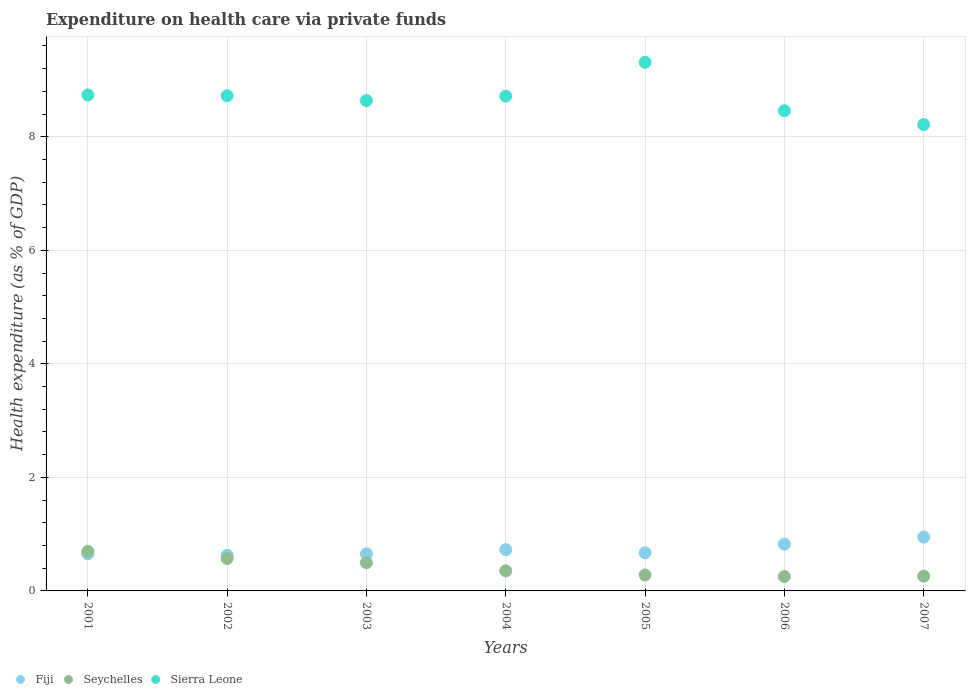How many different coloured dotlines are there?
Your response must be concise. 3. What is the expenditure made on health care in Fiji in 2006?
Your answer should be compact. 0.82. Across all years, what is the maximum expenditure made on health care in Seychelles?
Offer a terse response. 0.7. Across all years, what is the minimum expenditure made on health care in Fiji?
Offer a very short reply. 0.63. In which year was the expenditure made on health care in Sierra Leone maximum?
Offer a very short reply. 2005. What is the total expenditure made on health care in Sierra Leone in the graph?
Offer a terse response. 60.8. What is the difference between the expenditure made on health care in Sierra Leone in 2005 and that in 2006?
Give a very brief answer. 0.85. What is the difference between the expenditure made on health care in Sierra Leone in 2006 and the expenditure made on health care in Seychelles in 2005?
Your response must be concise. 8.18. What is the average expenditure made on health care in Sierra Leone per year?
Ensure brevity in your answer.  8.69. In the year 2003, what is the difference between the expenditure made on health care in Seychelles and expenditure made on health care in Fiji?
Provide a succinct answer. -0.16. What is the ratio of the expenditure made on health care in Seychelles in 2005 to that in 2007?
Provide a succinct answer. 1.08. Is the difference between the expenditure made on health care in Seychelles in 2004 and 2006 greater than the difference between the expenditure made on health care in Fiji in 2004 and 2006?
Your answer should be very brief. Yes. What is the difference between the highest and the second highest expenditure made on health care in Fiji?
Offer a terse response. 0.12. What is the difference between the highest and the lowest expenditure made on health care in Seychelles?
Your answer should be very brief. 0.44. Is the sum of the expenditure made on health care in Fiji in 2003 and 2006 greater than the maximum expenditure made on health care in Sierra Leone across all years?
Offer a very short reply. No. Is it the case that in every year, the sum of the expenditure made on health care in Seychelles and expenditure made on health care in Sierra Leone  is greater than the expenditure made on health care in Fiji?
Your answer should be compact. Yes. Does the expenditure made on health care in Sierra Leone monotonically increase over the years?
Provide a short and direct response. No. How many dotlines are there?
Keep it short and to the point. 3. What is the difference between two consecutive major ticks on the Y-axis?
Make the answer very short. 2. Does the graph contain any zero values?
Keep it short and to the point. No. What is the title of the graph?
Provide a short and direct response. Expenditure on health care via private funds. What is the label or title of the X-axis?
Offer a terse response. Years. What is the label or title of the Y-axis?
Keep it short and to the point. Health expenditure (as % of GDP). What is the Health expenditure (as % of GDP) of Fiji in 2001?
Offer a terse response. 0.65. What is the Health expenditure (as % of GDP) of Seychelles in 2001?
Keep it short and to the point. 0.7. What is the Health expenditure (as % of GDP) of Sierra Leone in 2001?
Your answer should be very brief. 8.74. What is the Health expenditure (as % of GDP) of Fiji in 2002?
Provide a short and direct response. 0.63. What is the Health expenditure (as % of GDP) of Seychelles in 2002?
Provide a short and direct response. 0.57. What is the Health expenditure (as % of GDP) of Sierra Leone in 2002?
Ensure brevity in your answer.  8.72. What is the Health expenditure (as % of GDP) in Fiji in 2003?
Offer a terse response. 0.65. What is the Health expenditure (as % of GDP) in Seychelles in 2003?
Your answer should be compact. 0.5. What is the Health expenditure (as % of GDP) of Sierra Leone in 2003?
Provide a succinct answer. 8.64. What is the Health expenditure (as % of GDP) in Fiji in 2004?
Offer a very short reply. 0.73. What is the Health expenditure (as % of GDP) in Seychelles in 2004?
Make the answer very short. 0.35. What is the Health expenditure (as % of GDP) of Sierra Leone in 2004?
Your response must be concise. 8.72. What is the Health expenditure (as % of GDP) in Fiji in 2005?
Offer a terse response. 0.67. What is the Health expenditure (as % of GDP) in Seychelles in 2005?
Your answer should be compact. 0.28. What is the Health expenditure (as % of GDP) of Sierra Leone in 2005?
Ensure brevity in your answer.  9.31. What is the Health expenditure (as % of GDP) in Fiji in 2006?
Ensure brevity in your answer.  0.82. What is the Health expenditure (as % of GDP) in Seychelles in 2006?
Your answer should be very brief. 0.25. What is the Health expenditure (as % of GDP) of Sierra Leone in 2006?
Offer a terse response. 8.46. What is the Health expenditure (as % of GDP) of Fiji in 2007?
Make the answer very short. 0.95. What is the Health expenditure (as % of GDP) in Seychelles in 2007?
Ensure brevity in your answer.  0.26. What is the Health expenditure (as % of GDP) of Sierra Leone in 2007?
Your answer should be compact. 8.21. Across all years, what is the maximum Health expenditure (as % of GDP) of Fiji?
Ensure brevity in your answer.  0.95. Across all years, what is the maximum Health expenditure (as % of GDP) of Seychelles?
Provide a succinct answer. 0.7. Across all years, what is the maximum Health expenditure (as % of GDP) in Sierra Leone?
Ensure brevity in your answer.  9.31. Across all years, what is the minimum Health expenditure (as % of GDP) of Fiji?
Give a very brief answer. 0.63. Across all years, what is the minimum Health expenditure (as % of GDP) in Seychelles?
Make the answer very short. 0.25. Across all years, what is the minimum Health expenditure (as % of GDP) in Sierra Leone?
Ensure brevity in your answer.  8.21. What is the total Health expenditure (as % of GDP) of Fiji in the graph?
Offer a very short reply. 5.1. What is the total Health expenditure (as % of GDP) of Seychelles in the graph?
Make the answer very short. 2.91. What is the total Health expenditure (as % of GDP) in Sierra Leone in the graph?
Offer a very short reply. 60.8. What is the difference between the Health expenditure (as % of GDP) of Fiji in 2001 and that in 2002?
Your answer should be very brief. 0.03. What is the difference between the Health expenditure (as % of GDP) in Seychelles in 2001 and that in 2002?
Provide a short and direct response. 0.13. What is the difference between the Health expenditure (as % of GDP) of Sierra Leone in 2001 and that in 2002?
Make the answer very short. 0.01. What is the difference between the Health expenditure (as % of GDP) of Fiji in 2001 and that in 2003?
Keep it short and to the point. 0. What is the difference between the Health expenditure (as % of GDP) of Seychelles in 2001 and that in 2003?
Provide a succinct answer. 0.2. What is the difference between the Health expenditure (as % of GDP) in Sierra Leone in 2001 and that in 2003?
Your answer should be compact. 0.1. What is the difference between the Health expenditure (as % of GDP) in Fiji in 2001 and that in 2004?
Your response must be concise. -0.07. What is the difference between the Health expenditure (as % of GDP) in Seychelles in 2001 and that in 2004?
Provide a short and direct response. 0.34. What is the difference between the Health expenditure (as % of GDP) in Sierra Leone in 2001 and that in 2004?
Give a very brief answer. 0.02. What is the difference between the Health expenditure (as % of GDP) in Fiji in 2001 and that in 2005?
Provide a succinct answer. -0.02. What is the difference between the Health expenditure (as % of GDP) in Seychelles in 2001 and that in 2005?
Your response must be concise. 0.42. What is the difference between the Health expenditure (as % of GDP) of Sierra Leone in 2001 and that in 2005?
Provide a succinct answer. -0.58. What is the difference between the Health expenditure (as % of GDP) in Fiji in 2001 and that in 2006?
Your answer should be compact. -0.17. What is the difference between the Health expenditure (as % of GDP) in Seychelles in 2001 and that in 2006?
Your answer should be compact. 0.44. What is the difference between the Health expenditure (as % of GDP) of Sierra Leone in 2001 and that in 2006?
Make the answer very short. 0.28. What is the difference between the Health expenditure (as % of GDP) of Fiji in 2001 and that in 2007?
Provide a short and direct response. -0.29. What is the difference between the Health expenditure (as % of GDP) in Seychelles in 2001 and that in 2007?
Your answer should be very brief. 0.44. What is the difference between the Health expenditure (as % of GDP) of Sierra Leone in 2001 and that in 2007?
Your answer should be very brief. 0.52. What is the difference between the Health expenditure (as % of GDP) in Fiji in 2002 and that in 2003?
Your response must be concise. -0.03. What is the difference between the Health expenditure (as % of GDP) in Seychelles in 2002 and that in 2003?
Your answer should be compact. 0.07. What is the difference between the Health expenditure (as % of GDP) of Sierra Leone in 2002 and that in 2003?
Ensure brevity in your answer.  0.09. What is the difference between the Health expenditure (as % of GDP) in Fiji in 2002 and that in 2004?
Your response must be concise. -0.1. What is the difference between the Health expenditure (as % of GDP) of Seychelles in 2002 and that in 2004?
Ensure brevity in your answer.  0.22. What is the difference between the Health expenditure (as % of GDP) in Sierra Leone in 2002 and that in 2004?
Give a very brief answer. 0.01. What is the difference between the Health expenditure (as % of GDP) of Fiji in 2002 and that in 2005?
Your response must be concise. -0.04. What is the difference between the Health expenditure (as % of GDP) in Seychelles in 2002 and that in 2005?
Your answer should be compact. 0.29. What is the difference between the Health expenditure (as % of GDP) of Sierra Leone in 2002 and that in 2005?
Offer a very short reply. -0.59. What is the difference between the Health expenditure (as % of GDP) of Fiji in 2002 and that in 2006?
Your answer should be compact. -0.2. What is the difference between the Health expenditure (as % of GDP) in Seychelles in 2002 and that in 2006?
Your answer should be compact. 0.32. What is the difference between the Health expenditure (as % of GDP) of Sierra Leone in 2002 and that in 2006?
Provide a succinct answer. 0.26. What is the difference between the Health expenditure (as % of GDP) in Fiji in 2002 and that in 2007?
Offer a very short reply. -0.32. What is the difference between the Health expenditure (as % of GDP) in Seychelles in 2002 and that in 2007?
Give a very brief answer. 0.31. What is the difference between the Health expenditure (as % of GDP) in Sierra Leone in 2002 and that in 2007?
Ensure brevity in your answer.  0.51. What is the difference between the Health expenditure (as % of GDP) in Fiji in 2003 and that in 2004?
Keep it short and to the point. -0.07. What is the difference between the Health expenditure (as % of GDP) in Seychelles in 2003 and that in 2004?
Provide a short and direct response. 0.14. What is the difference between the Health expenditure (as % of GDP) in Sierra Leone in 2003 and that in 2004?
Your answer should be very brief. -0.08. What is the difference between the Health expenditure (as % of GDP) in Fiji in 2003 and that in 2005?
Offer a terse response. -0.02. What is the difference between the Health expenditure (as % of GDP) of Seychelles in 2003 and that in 2005?
Offer a terse response. 0.22. What is the difference between the Health expenditure (as % of GDP) of Sierra Leone in 2003 and that in 2005?
Make the answer very short. -0.68. What is the difference between the Health expenditure (as % of GDP) in Fiji in 2003 and that in 2006?
Keep it short and to the point. -0.17. What is the difference between the Health expenditure (as % of GDP) in Seychelles in 2003 and that in 2006?
Ensure brevity in your answer.  0.24. What is the difference between the Health expenditure (as % of GDP) in Sierra Leone in 2003 and that in 2006?
Offer a very short reply. 0.18. What is the difference between the Health expenditure (as % of GDP) in Fiji in 2003 and that in 2007?
Keep it short and to the point. -0.3. What is the difference between the Health expenditure (as % of GDP) in Seychelles in 2003 and that in 2007?
Offer a very short reply. 0.24. What is the difference between the Health expenditure (as % of GDP) of Sierra Leone in 2003 and that in 2007?
Your answer should be very brief. 0.42. What is the difference between the Health expenditure (as % of GDP) in Fiji in 2004 and that in 2005?
Offer a very short reply. 0.05. What is the difference between the Health expenditure (as % of GDP) in Seychelles in 2004 and that in 2005?
Give a very brief answer. 0.07. What is the difference between the Health expenditure (as % of GDP) of Sierra Leone in 2004 and that in 2005?
Provide a succinct answer. -0.6. What is the difference between the Health expenditure (as % of GDP) of Fiji in 2004 and that in 2006?
Make the answer very short. -0.1. What is the difference between the Health expenditure (as % of GDP) in Sierra Leone in 2004 and that in 2006?
Your response must be concise. 0.26. What is the difference between the Health expenditure (as % of GDP) of Fiji in 2004 and that in 2007?
Offer a terse response. -0.22. What is the difference between the Health expenditure (as % of GDP) of Seychelles in 2004 and that in 2007?
Make the answer very short. 0.09. What is the difference between the Health expenditure (as % of GDP) of Sierra Leone in 2004 and that in 2007?
Give a very brief answer. 0.5. What is the difference between the Health expenditure (as % of GDP) in Fiji in 2005 and that in 2006?
Your answer should be very brief. -0.15. What is the difference between the Health expenditure (as % of GDP) of Seychelles in 2005 and that in 2006?
Offer a terse response. 0.03. What is the difference between the Health expenditure (as % of GDP) in Sierra Leone in 2005 and that in 2006?
Your answer should be compact. 0.85. What is the difference between the Health expenditure (as % of GDP) of Fiji in 2005 and that in 2007?
Give a very brief answer. -0.28. What is the difference between the Health expenditure (as % of GDP) of Seychelles in 2005 and that in 2007?
Your answer should be compact. 0.02. What is the difference between the Health expenditure (as % of GDP) in Sierra Leone in 2005 and that in 2007?
Make the answer very short. 1.1. What is the difference between the Health expenditure (as % of GDP) in Fiji in 2006 and that in 2007?
Your answer should be very brief. -0.12. What is the difference between the Health expenditure (as % of GDP) of Seychelles in 2006 and that in 2007?
Your response must be concise. -0.01. What is the difference between the Health expenditure (as % of GDP) in Sierra Leone in 2006 and that in 2007?
Your response must be concise. 0.24. What is the difference between the Health expenditure (as % of GDP) in Fiji in 2001 and the Health expenditure (as % of GDP) in Seychelles in 2002?
Give a very brief answer. 0.08. What is the difference between the Health expenditure (as % of GDP) in Fiji in 2001 and the Health expenditure (as % of GDP) in Sierra Leone in 2002?
Provide a succinct answer. -8.07. What is the difference between the Health expenditure (as % of GDP) in Seychelles in 2001 and the Health expenditure (as % of GDP) in Sierra Leone in 2002?
Your response must be concise. -8.02. What is the difference between the Health expenditure (as % of GDP) of Fiji in 2001 and the Health expenditure (as % of GDP) of Seychelles in 2003?
Give a very brief answer. 0.16. What is the difference between the Health expenditure (as % of GDP) in Fiji in 2001 and the Health expenditure (as % of GDP) in Sierra Leone in 2003?
Provide a short and direct response. -7.98. What is the difference between the Health expenditure (as % of GDP) of Seychelles in 2001 and the Health expenditure (as % of GDP) of Sierra Leone in 2003?
Ensure brevity in your answer.  -7.94. What is the difference between the Health expenditure (as % of GDP) of Fiji in 2001 and the Health expenditure (as % of GDP) of Seychelles in 2004?
Give a very brief answer. 0.3. What is the difference between the Health expenditure (as % of GDP) of Fiji in 2001 and the Health expenditure (as % of GDP) of Sierra Leone in 2004?
Ensure brevity in your answer.  -8.06. What is the difference between the Health expenditure (as % of GDP) of Seychelles in 2001 and the Health expenditure (as % of GDP) of Sierra Leone in 2004?
Provide a succinct answer. -8.02. What is the difference between the Health expenditure (as % of GDP) of Fiji in 2001 and the Health expenditure (as % of GDP) of Seychelles in 2005?
Give a very brief answer. 0.37. What is the difference between the Health expenditure (as % of GDP) in Fiji in 2001 and the Health expenditure (as % of GDP) in Sierra Leone in 2005?
Make the answer very short. -8.66. What is the difference between the Health expenditure (as % of GDP) of Seychelles in 2001 and the Health expenditure (as % of GDP) of Sierra Leone in 2005?
Your answer should be compact. -8.61. What is the difference between the Health expenditure (as % of GDP) of Fiji in 2001 and the Health expenditure (as % of GDP) of Seychelles in 2006?
Provide a short and direct response. 0.4. What is the difference between the Health expenditure (as % of GDP) of Fiji in 2001 and the Health expenditure (as % of GDP) of Sierra Leone in 2006?
Offer a terse response. -7.81. What is the difference between the Health expenditure (as % of GDP) in Seychelles in 2001 and the Health expenditure (as % of GDP) in Sierra Leone in 2006?
Give a very brief answer. -7.76. What is the difference between the Health expenditure (as % of GDP) of Fiji in 2001 and the Health expenditure (as % of GDP) of Seychelles in 2007?
Offer a very short reply. 0.39. What is the difference between the Health expenditure (as % of GDP) in Fiji in 2001 and the Health expenditure (as % of GDP) in Sierra Leone in 2007?
Your answer should be very brief. -7.56. What is the difference between the Health expenditure (as % of GDP) of Seychelles in 2001 and the Health expenditure (as % of GDP) of Sierra Leone in 2007?
Offer a terse response. -7.52. What is the difference between the Health expenditure (as % of GDP) in Fiji in 2002 and the Health expenditure (as % of GDP) in Seychelles in 2003?
Your answer should be very brief. 0.13. What is the difference between the Health expenditure (as % of GDP) of Fiji in 2002 and the Health expenditure (as % of GDP) of Sierra Leone in 2003?
Keep it short and to the point. -8.01. What is the difference between the Health expenditure (as % of GDP) of Seychelles in 2002 and the Health expenditure (as % of GDP) of Sierra Leone in 2003?
Offer a very short reply. -8.07. What is the difference between the Health expenditure (as % of GDP) of Fiji in 2002 and the Health expenditure (as % of GDP) of Seychelles in 2004?
Ensure brevity in your answer.  0.27. What is the difference between the Health expenditure (as % of GDP) in Fiji in 2002 and the Health expenditure (as % of GDP) in Sierra Leone in 2004?
Ensure brevity in your answer.  -8.09. What is the difference between the Health expenditure (as % of GDP) in Seychelles in 2002 and the Health expenditure (as % of GDP) in Sierra Leone in 2004?
Ensure brevity in your answer.  -8.15. What is the difference between the Health expenditure (as % of GDP) of Fiji in 2002 and the Health expenditure (as % of GDP) of Seychelles in 2005?
Keep it short and to the point. 0.35. What is the difference between the Health expenditure (as % of GDP) of Fiji in 2002 and the Health expenditure (as % of GDP) of Sierra Leone in 2005?
Your answer should be compact. -8.69. What is the difference between the Health expenditure (as % of GDP) in Seychelles in 2002 and the Health expenditure (as % of GDP) in Sierra Leone in 2005?
Provide a short and direct response. -8.74. What is the difference between the Health expenditure (as % of GDP) in Fiji in 2002 and the Health expenditure (as % of GDP) in Seychelles in 2006?
Your answer should be compact. 0.37. What is the difference between the Health expenditure (as % of GDP) of Fiji in 2002 and the Health expenditure (as % of GDP) of Sierra Leone in 2006?
Ensure brevity in your answer.  -7.83. What is the difference between the Health expenditure (as % of GDP) in Seychelles in 2002 and the Health expenditure (as % of GDP) in Sierra Leone in 2006?
Ensure brevity in your answer.  -7.89. What is the difference between the Health expenditure (as % of GDP) in Fiji in 2002 and the Health expenditure (as % of GDP) in Seychelles in 2007?
Provide a succinct answer. 0.37. What is the difference between the Health expenditure (as % of GDP) of Fiji in 2002 and the Health expenditure (as % of GDP) of Sierra Leone in 2007?
Your response must be concise. -7.59. What is the difference between the Health expenditure (as % of GDP) of Seychelles in 2002 and the Health expenditure (as % of GDP) of Sierra Leone in 2007?
Offer a terse response. -7.64. What is the difference between the Health expenditure (as % of GDP) of Fiji in 2003 and the Health expenditure (as % of GDP) of Seychelles in 2004?
Ensure brevity in your answer.  0.3. What is the difference between the Health expenditure (as % of GDP) in Fiji in 2003 and the Health expenditure (as % of GDP) in Sierra Leone in 2004?
Offer a terse response. -8.06. What is the difference between the Health expenditure (as % of GDP) of Seychelles in 2003 and the Health expenditure (as % of GDP) of Sierra Leone in 2004?
Offer a terse response. -8.22. What is the difference between the Health expenditure (as % of GDP) in Fiji in 2003 and the Health expenditure (as % of GDP) in Seychelles in 2005?
Keep it short and to the point. 0.37. What is the difference between the Health expenditure (as % of GDP) in Fiji in 2003 and the Health expenditure (as % of GDP) in Sierra Leone in 2005?
Offer a terse response. -8.66. What is the difference between the Health expenditure (as % of GDP) in Seychelles in 2003 and the Health expenditure (as % of GDP) in Sierra Leone in 2005?
Provide a short and direct response. -8.82. What is the difference between the Health expenditure (as % of GDP) in Fiji in 2003 and the Health expenditure (as % of GDP) in Seychelles in 2006?
Offer a very short reply. 0.4. What is the difference between the Health expenditure (as % of GDP) of Fiji in 2003 and the Health expenditure (as % of GDP) of Sierra Leone in 2006?
Provide a succinct answer. -7.81. What is the difference between the Health expenditure (as % of GDP) of Seychelles in 2003 and the Health expenditure (as % of GDP) of Sierra Leone in 2006?
Ensure brevity in your answer.  -7.96. What is the difference between the Health expenditure (as % of GDP) in Fiji in 2003 and the Health expenditure (as % of GDP) in Seychelles in 2007?
Your response must be concise. 0.39. What is the difference between the Health expenditure (as % of GDP) of Fiji in 2003 and the Health expenditure (as % of GDP) of Sierra Leone in 2007?
Give a very brief answer. -7.56. What is the difference between the Health expenditure (as % of GDP) in Seychelles in 2003 and the Health expenditure (as % of GDP) in Sierra Leone in 2007?
Keep it short and to the point. -7.72. What is the difference between the Health expenditure (as % of GDP) of Fiji in 2004 and the Health expenditure (as % of GDP) of Seychelles in 2005?
Your answer should be very brief. 0.45. What is the difference between the Health expenditure (as % of GDP) of Fiji in 2004 and the Health expenditure (as % of GDP) of Sierra Leone in 2005?
Make the answer very short. -8.59. What is the difference between the Health expenditure (as % of GDP) of Seychelles in 2004 and the Health expenditure (as % of GDP) of Sierra Leone in 2005?
Your answer should be very brief. -8.96. What is the difference between the Health expenditure (as % of GDP) in Fiji in 2004 and the Health expenditure (as % of GDP) in Seychelles in 2006?
Keep it short and to the point. 0.47. What is the difference between the Health expenditure (as % of GDP) of Fiji in 2004 and the Health expenditure (as % of GDP) of Sierra Leone in 2006?
Your response must be concise. -7.73. What is the difference between the Health expenditure (as % of GDP) in Seychelles in 2004 and the Health expenditure (as % of GDP) in Sierra Leone in 2006?
Provide a short and direct response. -8.1. What is the difference between the Health expenditure (as % of GDP) in Fiji in 2004 and the Health expenditure (as % of GDP) in Seychelles in 2007?
Your response must be concise. 0.47. What is the difference between the Health expenditure (as % of GDP) in Fiji in 2004 and the Health expenditure (as % of GDP) in Sierra Leone in 2007?
Provide a succinct answer. -7.49. What is the difference between the Health expenditure (as % of GDP) of Seychelles in 2004 and the Health expenditure (as % of GDP) of Sierra Leone in 2007?
Offer a terse response. -7.86. What is the difference between the Health expenditure (as % of GDP) of Fiji in 2005 and the Health expenditure (as % of GDP) of Seychelles in 2006?
Offer a very short reply. 0.42. What is the difference between the Health expenditure (as % of GDP) of Fiji in 2005 and the Health expenditure (as % of GDP) of Sierra Leone in 2006?
Your answer should be very brief. -7.79. What is the difference between the Health expenditure (as % of GDP) in Seychelles in 2005 and the Health expenditure (as % of GDP) in Sierra Leone in 2006?
Ensure brevity in your answer.  -8.18. What is the difference between the Health expenditure (as % of GDP) in Fiji in 2005 and the Health expenditure (as % of GDP) in Seychelles in 2007?
Keep it short and to the point. 0.41. What is the difference between the Health expenditure (as % of GDP) in Fiji in 2005 and the Health expenditure (as % of GDP) in Sierra Leone in 2007?
Provide a short and direct response. -7.54. What is the difference between the Health expenditure (as % of GDP) of Seychelles in 2005 and the Health expenditure (as % of GDP) of Sierra Leone in 2007?
Provide a succinct answer. -7.93. What is the difference between the Health expenditure (as % of GDP) of Fiji in 2006 and the Health expenditure (as % of GDP) of Seychelles in 2007?
Provide a succinct answer. 0.56. What is the difference between the Health expenditure (as % of GDP) in Fiji in 2006 and the Health expenditure (as % of GDP) in Sierra Leone in 2007?
Your answer should be very brief. -7.39. What is the difference between the Health expenditure (as % of GDP) in Seychelles in 2006 and the Health expenditure (as % of GDP) in Sierra Leone in 2007?
Your answer should be compact. -7.96. What is the average Health expenditure (as % of GDP) of Fiji per year?
Your answer should be very brief. 0.73. What is the average Health expenditure (as % of GDP) of Seychelles per year?
Your answer should be very brief. 0.42. What is the average Health expenditure (as % of GDP) in Sierra Leone per year?
Offer a very short reply. 8.69. In the year 2001, what is the difference between the Health expenditure (as % of GDP) of Fiji and Health expenditure (as % of GDP) of Seychelles?
Ensure brevity in your answer.  -0.04. In the year 2001, what is the difference between the Health expenditure (as % of GDP) in Fiji and Health expenditure (as % of GDP) in Sierra Leone?
Provide a short and direct response. -8.08. In the year 2001, what is the difference between the Health expenditure (as % of GDP) in Seychelles and Health expenditure (as % of GDP) in Sierra Leone?
Your answer should be very brief. -8.04. In the year 2002, what is the difference between the Health expenditure (as % of GDP) of Fiji and Health expenditure (as % of GDP) of Seychelles?
Give a very brief answer. 0.06. In the year 2002, what is the difference between the Health expenditure (as % of GDP) in Fiji and Health expenditure (as % of GDP) in Sierra Leone?
Keep it short and to the point. -8.1. In the year 2002, what is the difference between the Health expenditure (as % of GDP) in Seychelles and Health expenditure (as % of GDP) in Sierra Leone?
Your answer should be compact. -8.15. In the year 2003, what is the difference between the Health expenditure (as % of GDP) in Fiji and Health expenditure (as % of GDP) in Seychelles?
Provide a succinct answer. 0.16. In the year 2003, what is the difference between the Health expenditure (as % of GDP) of Fiji and Health expenditure (as % of GDP) of Sierra Leone?
Your answer should be compact. -7.98. In the year 2003, what is the difference between the Health expenditure (as % of GDP) of Seychelles and Health expenditure (as % of GDP) of Sierra Leone?
Make the answer very short. -8.14. In the year 2004, what is the difference between the Health expenditure (as % of GDP) of Fiji and Health expenditure (as % of GDP) of Seychelles?
Provide a short and direct response. 0.37. In the year 2004, what is the difference between the Health expenditure (as % of GDP) in Fiji and Health expenditure (as % of GDP) in Sierra Leone?
Offer a very short reply. -7.99. In the year 2004, what is the difference between the Health expenditure (as % of GDP) of Seychelles and Health expenditure (as % of GDP) of Sierra Leone?
Keep it short and to the point. -8.36. In the year 2005, what is the difference between the Health expenditure (as % of GDP) of Fiji and Health expenditure (as % of GDP) of Seychelles?
Provide a succinct answer. 0.39. In the year 2005, what is the difference between the Health expenditure (as % of GDP) in Fiji and Health expenditure (as % of GDP) in Sierra Leone?
Your response must be concise. -8.64. In the year 2005, what is the difference between the Health expenditure (as % of GDP) in Seychelles and Health expenditure (as % of GDP) in Sierra Leone?
Offer a terse response. -9.03. In the year 2006, what is the difference between the Health expenditure (as % of GDP) of Fiji and Health expenditure (as % of GDP) of Seychelles?
Offer a terse response. 0.57. In the year 2006, what is the difference between the Health expenditure (as % of GDP) of Fiji and Health expenditure (as % of GDP) of Sierra Leone?
Give a very brief answer. -7.63. In the year 2006, what is the difference between the Health expenditure (as % of GDP) of Seychelles and Health expenditure (as % of GDP) of Sierra Leone?
Make the answer very short. -8.2. In the year 2007, what is the difference between the Health expenditure (as % of GDP) of Fiji and Health expenditure (as % of GDP) of Seychelles?
Ensure brevity in your answer.  0.69. In the year 2007, what is the difference between the Health expenditure (as % of GDP) of Fiji and Health expenditure (as % of GDP) of Sierra Leone?
Keep it short and to the point. -7.27. In the year 2007, what is the difference between the Health expenditure (as % of GDP) of Seychelles and Health expenditure (as % of GDP) of Sierra Leone?
Keep it short and to the point. -7.96. What is the ratio of the Health expenditure (as % of GDP) of Fiji in 2001 to that in 2002?
Provide a short and direct response. 1.04. What is the ratio of the Health expenditure (as % of GDP) of Seychelles in 2001 to that in 2002?
Give a very brief answer. 1.22. What is the ratio of the Health expenditure (as % of GDP) of Sierra Leone in 2001 to that in 2002?
Offer a very short reply. 1. What is the ratio of the Health expenditure (as % of GDP) of Seychelles in 2001 to that in 2003?
Keep it short and to the point. 1.4. What is the ratio of the Health expenditure (as % of GDP) of Sierra Leone in 2001 to that in 2003?
Make the answer very short. 1.01. What is the ratio of the Health expenditure (as % of GDP) of Fiji in 2001 to that in 2004?
Your answer should be very brief. 0.9. What is the ratio of the Health expenditure (as % of GDP) of Seychelles in 2001 to that in 2004?
Your response must be concise. 1.97. What is the ratio of the Health expenditure (as % of GDP) in Fiji in 2001 to that in 2005?
Ensure brevity in your answer.  0.97. What is the ratio of the Health expenditure (as % of GDP) in Seychelles in 2001 to that in 2005?
Ensure brevity in your answer.  2.48. What is the ratio of the Health expenditure (as % of GDP) of Sierra Leone in 2001 to that in 2005?
Offer a terse response. 0.94. What is the ratio of the Health expenditure (as % of GDP) of Fiji in 2001 to that in 2006?
Your response must be concise. 0.79. What is the ratio of the Health expenditure (as % of GDP) of Seychelles in 2001 to that in 2006?
Ensure brevity in your answer.  2.75. What is the ratio of the Health expenditure (as % of GDP) in Sierra Leone in 2001 to that in 2006?
Keep it short and to the point. 1.03. What is the ratio of the Health expenditure (as % of GDP) of Fiji in 2001 to that in 2007?
Ensure brevity in your answer.  0.69. What is the ratio of the Health expenditure (as % of GDP) of Seychelles in 2001 to that in 2007?
Offer a terse response. 2.69. What is the ratio of the Health expenditure (as % of GDP) in Sierra Leone in 2001 to that in 2007?
Offer a very short reply. 1.06. What is the ratio of the Health expenditure (as % of GDP) in Fiji in 2002 to that in 2003?
Your response must be concise. 0.96. What is the ratio of the Health expenditure (as % of GDP) of Seychelles in 2002 to that in 2003?
Ensure brevity in your answer.  1.15. What is the ratio of the Health expenditure (as % of GDP) in Sierra Leone in 2002 to that in 2003?
Give a very brief answer. 1.01. What is the ratio of the Health expenditure (as % of GDP) in Fiji in 2002 to that in 2004?
Give a very brief answer. 0.86. What is the ratio of the Health expenditure (as % of GDP) of Seychelles in 2002 to that in 2004?
Your response must be concise. 1.61. What is the ratio of the Health expenditure (as % of GDP) of Fiji in 2002 to that in 2005?
Your response must be concise. 0.93. What is the ratio of the Health expenditure (as % of GDP) of Seychelles in 2002 to that in 2005?
Offer a terse response. 2.03. What is the ratio of the Health expenditure (as % of GDP) in Sierra Leone in 2002 to that in 2005?
Offer a very short reply. 0.94. What is the ratio of the Health expenditure (as % of GDP) of Fiji in 2002 to that in 2006?
Your response must be concise. 0.76. What is the ratio of the Health expenditure (as % of GDP) in Seychelles in 2002 to that in 2006?
Your answer should be compact. 2.25. What is the ratio of the Health expenditure (as % of GDP) of Sierra Leone in 2002 to that in 2006?
Your response must be concise. 1.03. What is the ratio of the Health expenditure (as % of GDP) in Fiji in 2002 to that in 2007?
Offer a very short reply. 0.66. What is the ratio of the Health expenditure (as % of GDP) in Seychelles in 2002 to that in 2007?
Make the answer very short. 2.2. What is the ratio of the Health expenditure (as % of GDP) of Sierra Leone in 2002 to that in 2007?
Your answer should be very brief. 1.06. What is the ratio of the Health expenditure (as % of GDP) in Fiji in 2003 to that in 2004?
Provide a succinct answer. 0.9. What is the ratio of the Health expenditure (as % of GDP) of Seychelles in 2003 to that in 2004?
Offer a very short reply. 1.4. What is the ratio of the Health expenditure (as % of GDP) of Sierra Leone in 2003 to that in 2004?
Offer a very short reply. 0.99. What is the ratio of the Health expenditure (as % of GDP) in Fiji in 2003 to that in 2005?
Offer a very short reply. 0.97. What is the ratio of the Health expenditure (as % of GDP) in Seychelles in 2003 to that in 2005?
Ensure brevity in your answer.  1.77. What is the ratio of the Health expenditure (as % of GDP) of Sierra Leone in 2003 to that in 2005?
Make the answer very short. 0.93. What is the ratio of the Health expenditure (as % of GDP) in Fiji in 2003 to that in 2006?
Keep it short and to the point. 0.79. What is the ratio of the Health expenditure (as % of GDP) in Seychelles in 2003 to that in 2006?
Make the answer very short. 1.96. What is the ratio of the Health expenditure (as % of GDP) in Sierra Leone in 2003 to that in 2006?
Make the answer very short. 1.02. What is the ratio of the Health expenditure (as % of GDP) in Fiji in 2003 to that in 2007?
Ensure brevity in your answer.  0.69. What is the ratio of the Health expenditure (as % of GDP) of Seychelles in 2003 to that in 2007?
Your answer should be very brief. 1.91. What is the ratio of the Health expenditure (as % of GDP) in Sierra Leone in 2003 to that in 2007?
Provide a succinct answer. 1.05. What is the ratio of the Health expenditure (as % of GDP) in Fiji in 2004 to that in 2005?
Ensure brevity in your answer.  1.08. What is the ratio of the Health expenditure (as % of GDP) in Seychelles in 2004 to that in 2005?
Your response must be concise. 1.26. What is the ratio of the Health expenditure (as % of GDP) of Sierra Leone in 2004 to that in 2005?
Make the answer very short. 0.94. What is the ratio of the Health expenditure (as % of GDP) in Fiji in 2004 to that in 2006?
Provide a succinct answer. 0.88. What is the ratio of the Health expenditure (as % of GDP) of Seychelles in 2004 to that in 2006?
Offer a terse response. 1.39. What is the ratio of the Health expenditure (as % of GDP) of Sierra Leone in 2004 to that in 2006?
Make the answer very short. 1.03. What is the ratio of the Health expenditure (as % of GDP) in Fiji in 2004 to that in 2007?
Offer a terse response. 0.77. What is the ratio of the Health expenditure (as % of GDP) of Seychelles in 2004 to that in 2007?
Make the answer very short. 1.36. What is the ratio of the Health expenditure (as % of GDP) of Sierra Leone in 2004 to that in 2007?
Ensure brevity in your answer.  1.06. What is the ratio of the Health expenditure (as % of GDP) of Fiji in 2005 to that in 2006?
Your answer should be compact. 0.82. What is the ratio of the Health expenditure (as % of GDP) of Seychelles in 2005 to that in 2006?
Offer a terse response. 1.11. What is the ratio of the Health expenditure (as % of GDP) in Sierra Leone in 2005 to that in 2006?
Offer a terse response. 1.1. What is the ratio of the Health expenditure (as % of GDP) of Fiji in 2005 to that in 2007?
Your answer should be very brief. 0.71. What is the ratio of the Health expenditure (as % of GDP) of Seychelles in 2005 to that in 2007?
Offer a very short reply. 1.08. What is the ratio of the Health expenditure (as % of GDP) in Sierra Leone in 2005 to that in 2007?
Your answer should be compact. 1.13. What is the ratio of the Health expenditure (as % of GDP) of Fiji in 2006 to that in 2007?
Provide a short and direct response. 0.87. What is the ratio of the Health expenditure (as % of GDP) in Seychelles in 2006 to that in 2007?
Provide a short and direct response. 0.98. What is the ratio of the Health expenditure (as % of GDP) in Sierra Leone in 2006 to that in 2007?
Provide a succinct answer. 1.03. What is the difference between the highest and the second highest Health expenditure (as % of GDP) of Fiji?
Your response must be concise. 0.12. What is the difference between the highest and the second highest Health expenditure (as % of GDP) in Seychelles?
Make the answer very short. 0.13. What is the difference between the highest and the second highest Health expenditure (as % of GDP) in Sierra Leone?
Offer a terse response. 0.58. What is the difference between the highest and the lowest Health expenditure (as % of GDP) of Fiji?
Keep it short and to the point. 0.32. What is the difference between the highest and the lowest Health expenditure (as % of GDP) of Seychelles?
Your answer should be very brief. 0.44. What is the difference between the highest and the lowest Health expenditure (as % of GDP) in Sierra Leone?
Keep it short and to the point. 1.1. 